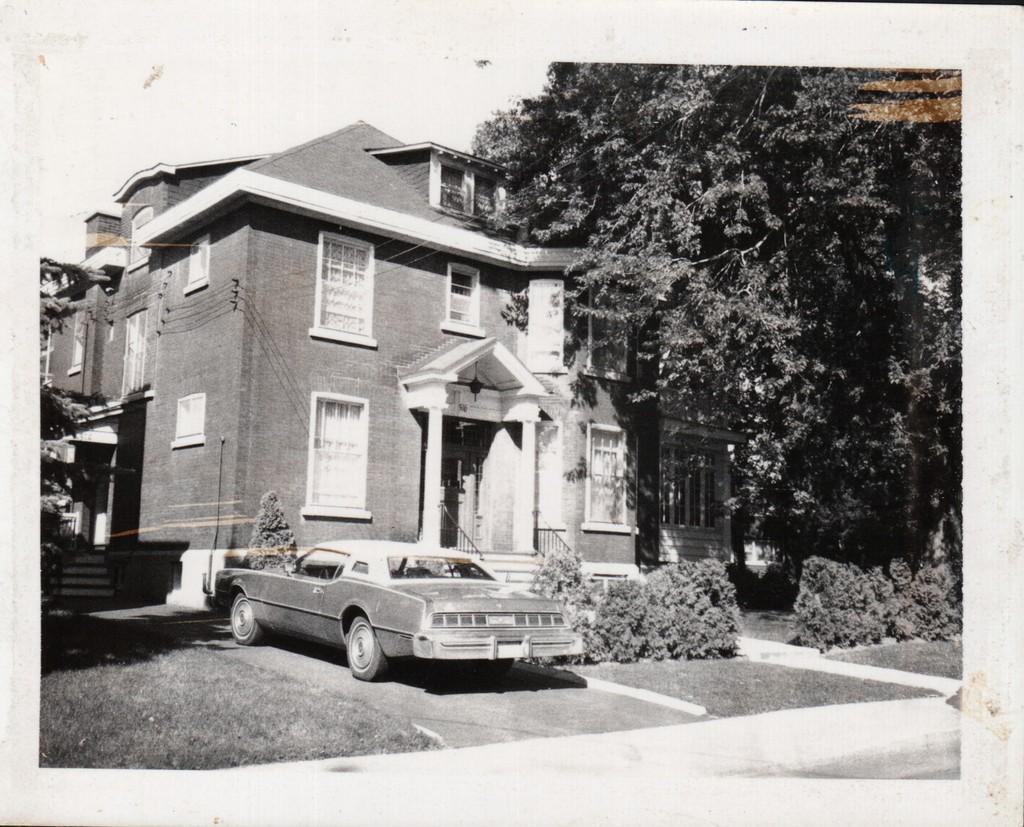Can you describe this image briefly? In this image I can observe a building and a car parked in front of the building. There are some trees present at the right side of the image. 